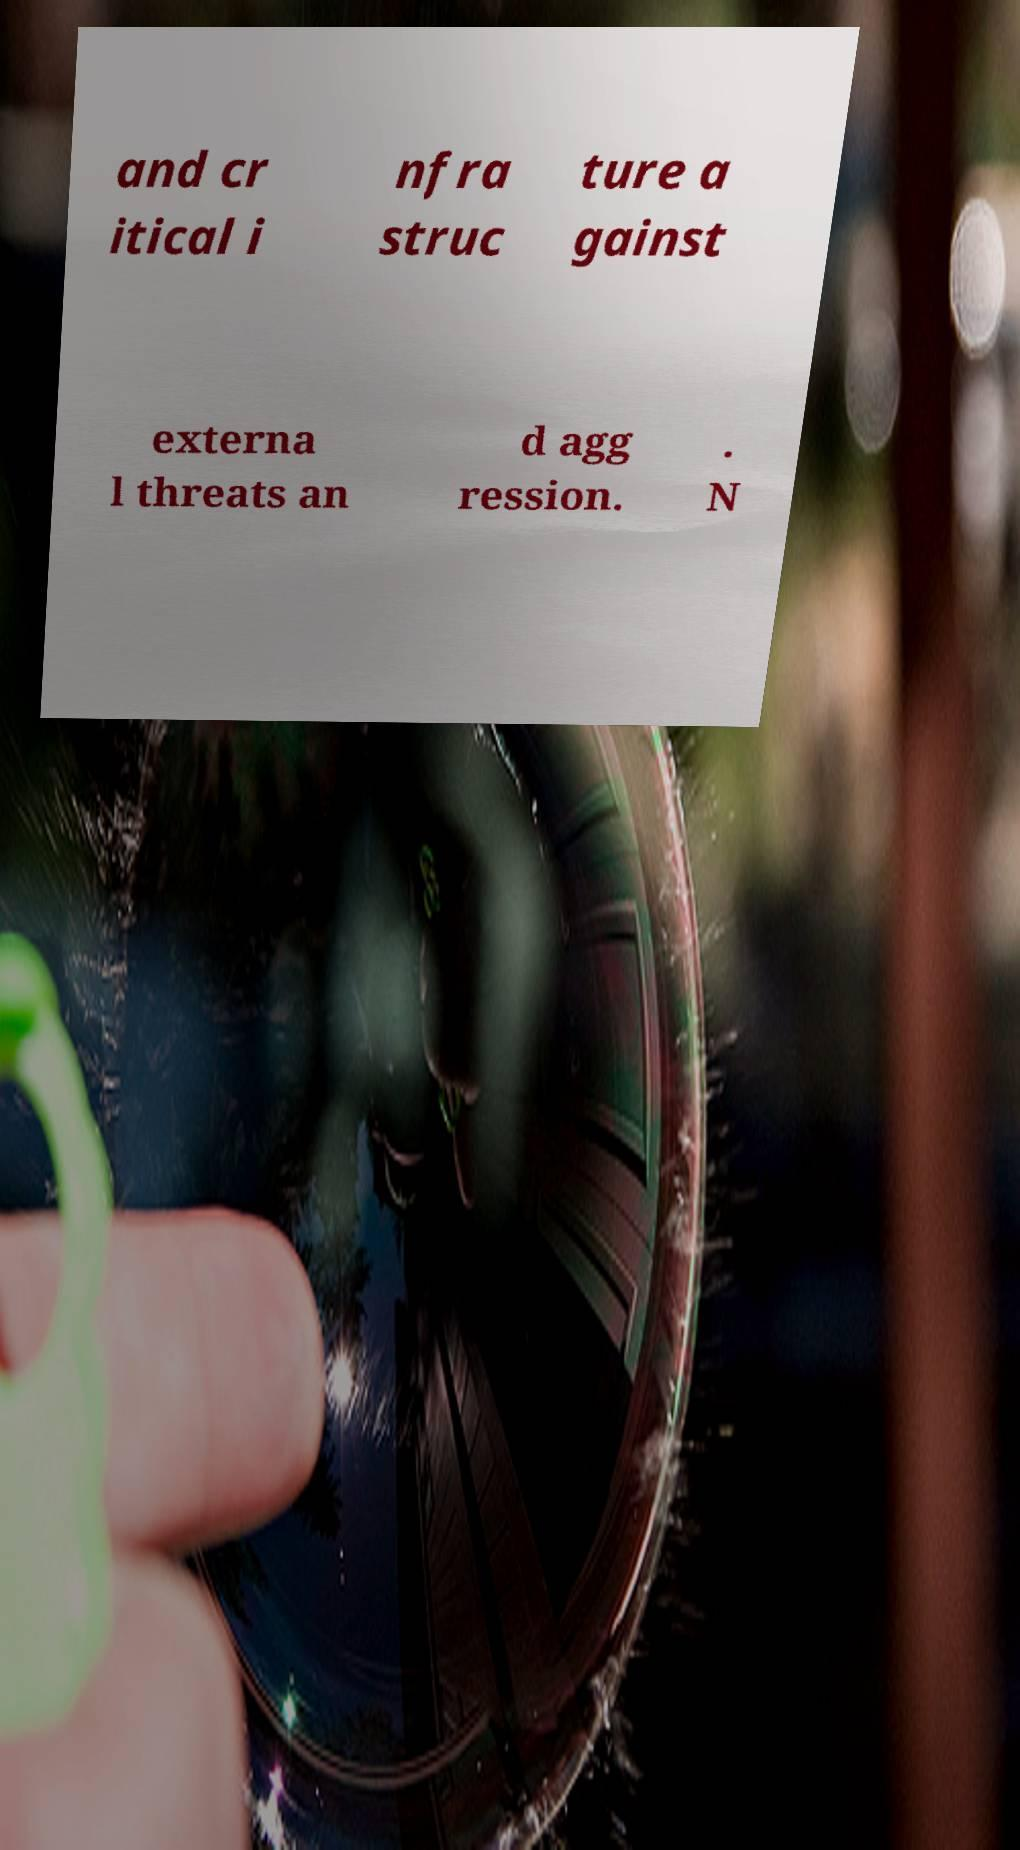Can you read and provide the text displayed in the image?This photo seems to have some interesting text. Can you extract and type it out for me? and cr itical i nfra struc ture a gainst externa l threats an d agg ression. . N 